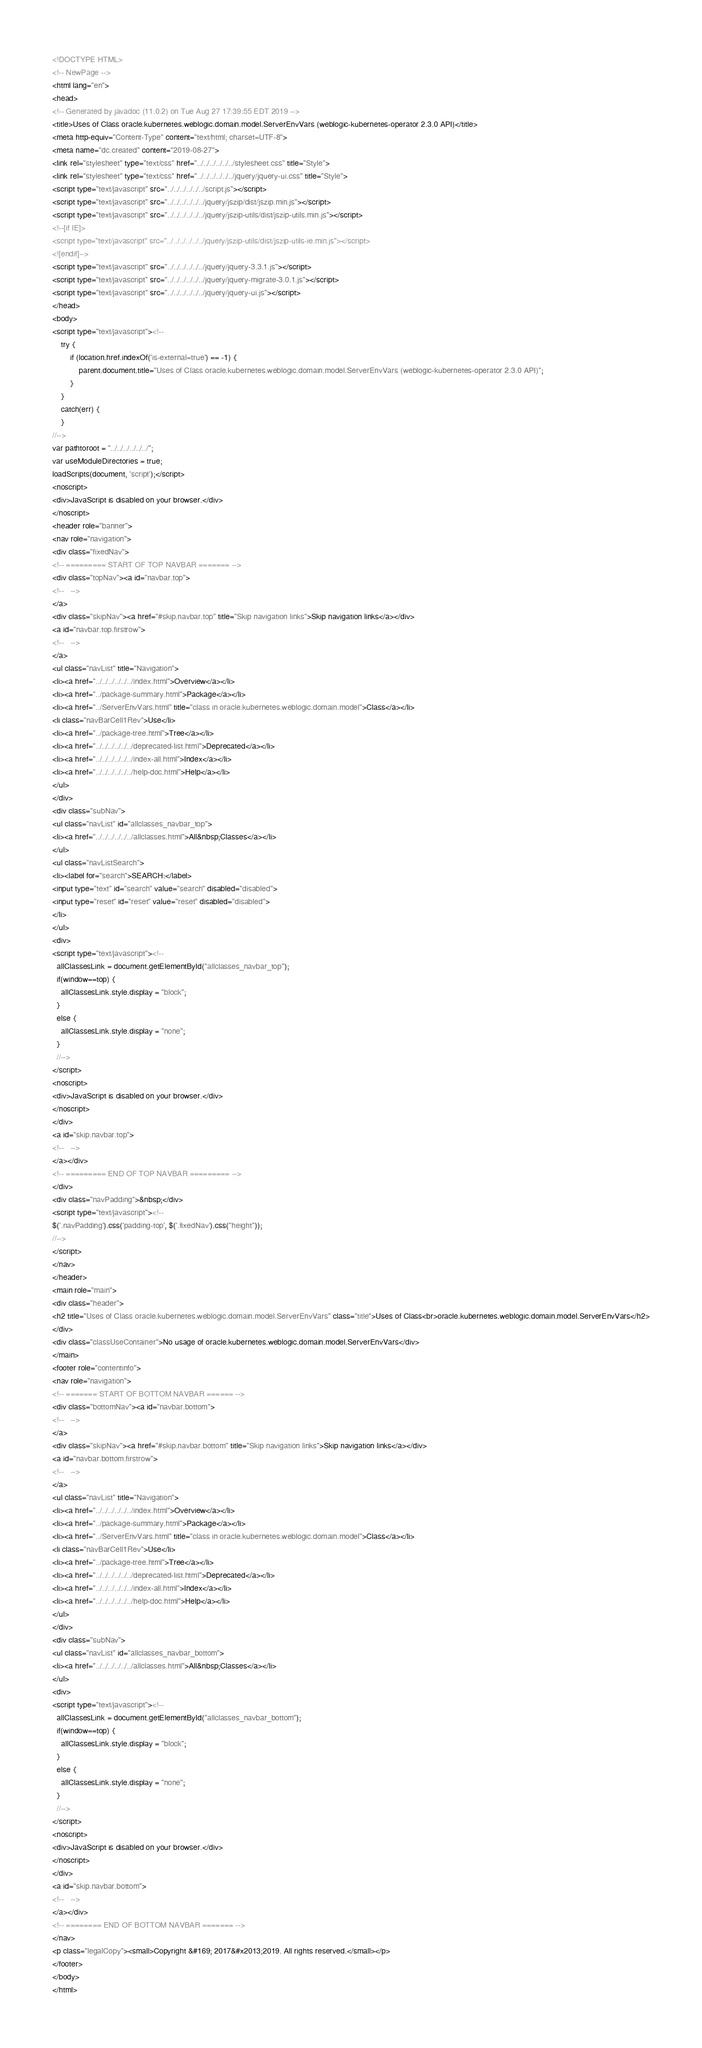<code> <loc_0><loc_0><loc_500><loc_500><_HTML_><!DOCTYPE HTML>
<!-- NewPage -->
<html lang="en">
<head>
<!-- Generated by javadoc (11.0.2) on Tue Aug 27 17:39:55 EDT 2019 -->
<title>Uses of Class oracle.kubernetes.weblogic.domain.model.ServerEnvVars (weblogic-kubernetes-operator 2.3.0 API)</title>
<meta http-equiv="Content-Type" content="text/html; charset=UTF-8">
<meta name="dc.created" content="2019-08-27">
<link rel="stylesheet" type="text/css" href="../../../../../../stylesheet.css" title="Style">
<link rel="stylesheet" type="text/css" href="../../../../../../jquery/jquery-ui.css" title="Style">
<script type="text/javascript" src="../../../../../../script.js"></script>
<script type="text/javascript" src="../../../../../../jquery/jszip/dist/jszip.min.js"></script>
<script type="text/javascript" src="../../../../../../jquery/jszip-utils/dist/jszip-utils.min.js"></script>
<!--[if IE]>
<script type="text/javascript" src="../../../../../../jquery/jszip-utils/dist/jszip-utils-ie.min.js"></script>
<![endif]-->
<script type="text/javascript" src="../../../../../../jquery/jquery-3.3.1.js"></script>
<script type="text/javascript" src="../../../../../../jquery/jquery-migrate-3.0.1.js"></script>
<script type="text/javascript" src="../../../../../../jquery/jquery-ui.js"></script>
</head>
<body>
<script type="text/javascript"><!--
    try {
        if (location.href.indexOf('is-external=true') == -1) {
            parent.document.title="Uses of Class oracle.kubernetes.weblogic.domain.model.ServerEnvVars (weblogic-kubernetes-operator 2.3.0 API)";
        }
    }
    catch(err) {
    }
//-->
var pathtoroot = "../../../../../../";
var useModuleDirectories = true;
loadScripts(document, 'script');</script>
<noscript>
<div>JavaScript is disabled on your browser.</div>
</noscript>
<header role="banner">
<nav role="navigation">
<div class="fixedNav">
<!-- ========= START OF TOP NAVBAR ======= -->
<div class="topNav"><a id="navbar.top">
<!--   -->
</a>
<div class="skipNav"><a href="#skip.navbar.top" title="Skip navigation links">Skip navigation links</a></div>
<a id="navbar.top.firstrow">
<!--   -->
</a>
<ul class="navList" title="Navigation">
<li><a href="../../../../../../index.html">Overview</a></li>
<li><a href="../package-summary.html">Package</a></li>
<li><a href="../ServerEnvVars.html" title="class in oracle.kubernetes.weblogic.domain.model">Class</a></li>
<li class="navBarCell1Rev">Use</li>
<li><a href="../package-tree.html">Tree</a></li>
<li><a href="../../../../../../deprecated-list.html">Deprecated</a></li>
<li><a href="../../../../../../index-all.html">Index</a></li>
<li><a href="../../../../../../help-doc.html">Help</a></li>
</ul>
</div>
<div class="subNav">
<ul class="navList" id="allclasses_navbar_top">
<li><a href="../../../../../../allclasses.html">All&nbsp;Classes</a></li>
</ul>
<ul class="navListSearch">
<li><label for="search">SEARCH:</label>
<input type="text" id="search" value="search" disabled="disabled">
<input type="reset" id="reset" value="reset" disabled="disabled">
</li>
</ul>
<div>
<script type="text/javascript"><!--
  allClassesLink = document.getElementById("allclasses_navbar_top");
  if(window==top) {
    allClassesLink.style.display = "block";
  }
  else {
    allClassesLink.style.display = "none";
  }
  //-->
</script>
<noscript>
<div>JavaScript is disabled on your browser.</div>
</noscript>
</div>
<a id="skip.navbar.top">
<!--   -->
</a></div>
<!-- ========= END OF TOP NAVBAR ========= -->
</div>
<div class="navPadding">&nbsp;</div>
<script type="text/javascript"><!--
$('.navPadding').css('padding-top', $('.fixedNav').css("height"));
//-->
</script>
</nav>
</header>
<main role="main">
<div class="header">
<h2 title="Uses of Class oracle.kubernetes.weblogic.domain.model.ServerEnvVars" class="title">Uses of Class<br>oracle.kubernetes.weblogic.domain.model.ServerEnvVars</h2>
</div>
<div class="classUseContainer">No usage of oracle.kubernetes.weblogic.domain.model.ServerEnvVars</div>
</main>
<footer role="contentinfo">
<nav role="navigation">
<!-- ======= START OF BOTTOM NAVBAR ====== -->
<div class="bottomNav"><a id="navbar.bottom">
<!--   -->
</a>
<div class="skipNav"><a href="#skip.navbar.bottom" title="Skip navigation links">Skip navigation links</a></div>
<a id="navbar.bottom.firstrow">
<!--   -->
</a>
<ul class="navList" title="Navigation">
<li><a href="../../../../../../index.html">Overview</a></li>
<li><a href="../package-summary.html">Package</a></li>
<li><a href="../ServerEnvVars.html" title="class in oracle.kubernetes.weblogic.domain.model">Class</a></li>
<li class="navBarCell1Rev">Use</li>
<li><a href="../package-tree.html">Tree</a></li>
<li><a href="../../../../../../deprecated-list.html">Deprecated</a></li>
<li><a href="../../../../../../index-all.html">Index</a></li>
<li><a href="../../../../../../help-doc.html">Help</a></li>
</ul>
</div>
<div class="subNav">
<ul class="navList" id="allclasses_navbar_bottom">
<li><a href="../../../../../../allclasses.html">All&nbsp;Classes</a></li>
</ul>
<div>
<script type="text/javascript"><!--
  allClassesLink = document.getElementById("allclasses_navbar_bottom");
  if(window==top) {
    allClassesLink.style.display = "block";
  }
  else {
    allClassesLink.style.display = "none";
  }
  //-->
</script>
<noscript>
<div>JavaScript is disabled on your browser.</div>
</noscript>
</div>
<a id="skip.navbar.bottom">
<!--   -->
</a></div>
<!-- ======== END OF BOTTOM NAVBAR ======= -->
</nav>
<p class="legalCopy"><small>Copyright &#169; 2017&#x2013;2019. All rights reserved.</small></p>
</footer>
</body>
</html>
</code> 